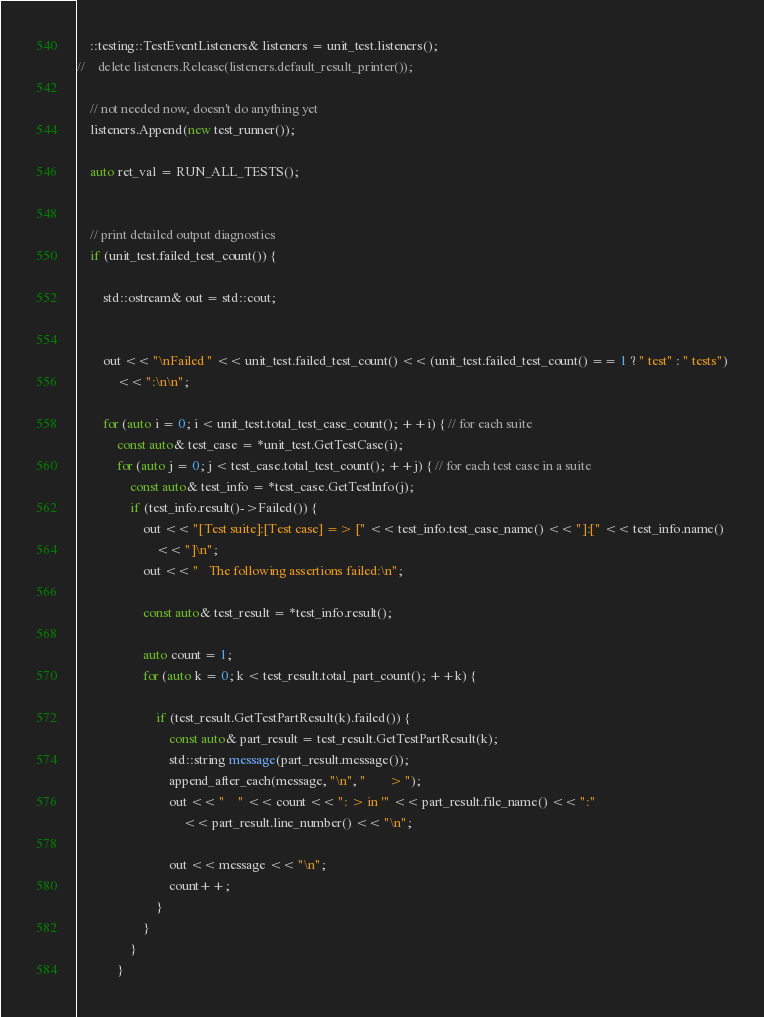Convert code to text. <code><loc_0><loc_0><loc_500><loc_500><_C++_>    ::testing::TestEventListeners& listeners = unit_test.listeners();
//    delete listeners.Release(listeners.default_result_printer());

    // not needed now, doesn't do anything yet
    listeners.Append(new test_runner());

    auto ret_val = RUN_ALL_TESTS();


    // print detailed output diagnostics
    if (unit_test.failed_test_count()) {

        std::ostream& out = std::cout;


        out << "\nFailed " << unit_test.failed_test_count() << (unit_test.failed_test_count() == 1 ? " test" : " tests")
            << ":\n\n";

        for (auto i = 0; i < unit_test.total_test_case_count(); ++i) { // for each suite
            const auto& test_case = *unit_test.GetTestCase(i);
            for (auto j = 0; j < test_case.total_test_count(); ++j) { // for each test case in a suite
                const auto& test_info = *test_case.GetTestInfo(j);
                if (test_info.result()->Failed()) {
                    out << "[Test suite]:[Test case] => [" << test_info.test_case_name() << "]:[" << test_info.name()
                        << "]\n";
                    out << "   The following assertions failed:\n";

                    const auto& test_result = *test_info.result();

                    auto count = 1;
                    for (auto k = 0; k < test_result.total_part_count(); ++k) {

                        if (test_result.GetTestPartResult(k).failed()) {
                            const auto& part_result = test_result.GetTestPartResult(k);
                            std::string message(part_result.message());
                            append_after_each(message, "\n", "       > ");
                            out << "    " << count << ": > in '" << part_result.file_name() << ":"
                                << part_result.line_number() << "\n";

                            out << message << "\n";
                            count++;
                        }
                    }
                }
            }</code> 